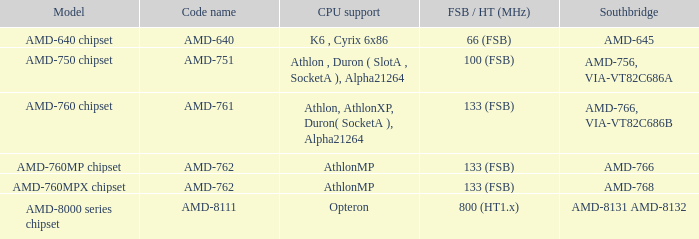What is the southbridge when the cpu compatibility was athlon, athlon xp, duron (socket a), alpha 21264? AMD-766, VIA-VT82C686B. 